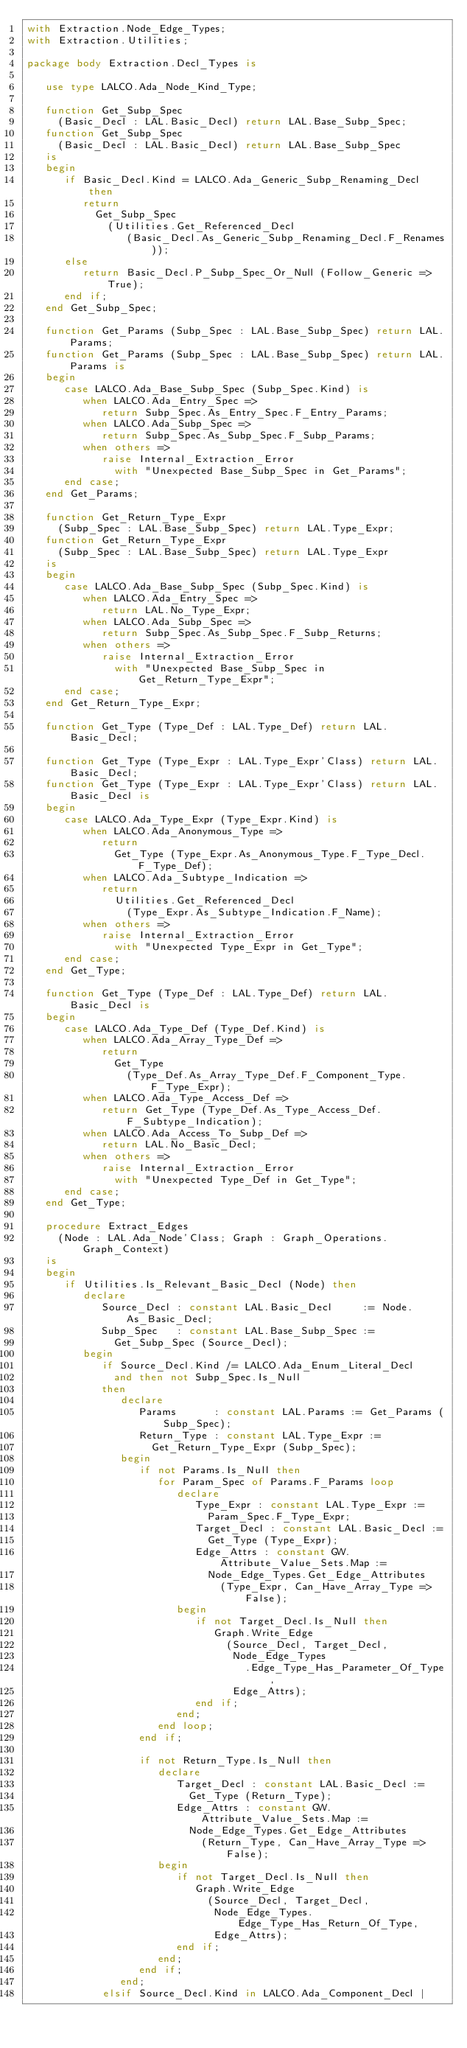Convert code to text. <code><loc_0><loc_0><loc_500><loc_500><_Ada_>with Extraction.Node_Edge_Types;
with Extraction.Utilities;

package body Extraction.Decl_Types is

   use type LALCO.Ada_Node_Kind_Type;

   function Get_Subp_Spec
     (Basic_Decl : LAL.Basic_Decl) return LAL.Base_Subp_Spec;
   function Get_Subp_Spec
     (Basic_Decl : LAL.Basic_Decl) return LAL.Base_Subp_Spec
   is
   begin
      if Basic_Decl.Kind = LALCO.Ada_Generic_Subp_Renaming_Decl then
         return
           Get_Subp_Spec
             (Utilities.Get_Referenced_Decl
                (Basic_Decl.As_Generic_Subp_Renaming_Decl.F_Renames));
      else
         return Basic_Decl.P_Subp_Spec_Or_Null (Follow_Generic => True);
      end if;
   end Get_Subp_Spec;

   function Get_Params (Subp_Spec : LAL.Base_Subp_Spec) return LAL.Params;
   function Get_Params (Subp_Spec : LAL.Base_Subp_Spec) return LAL.Params is
   begin
      case LALCO.Ada_Base_Subp_Spec (Subp_Spec.Kind) is
         when LALCO.Ada_Entry_Spec =>
            return Subp_Spec.As_Entry_Spec.F_Entry_Params;
         when LALCO.Ada_Subp_Spec =>
            return Subp_Spec.As_Subp_Spec.F_Subp_Params;
         when others =>
            raise Internal_Extraction_Error
              with "Unexpected Base_Subp_Spec in Get_Params";
      end case;
   end Get_Params;

   function Get_Return_Type_Expr
     (Subp_Spec : LAL.Base_Subp_Spec) return LAL.Type_Expr;
   function Get_Return_Type_Expr
     (Subp_Spec : LAL.Base_Subp_Spec) return LAL.Type_Expr
   is
   begin
      case LALCO.Ada_Base_Subp_Spec (Subp_Spec.Kind) is
         when LALCO.Ada_Entry_Spec =>
            return LAL.No_Type_Expr;
         when LALCO.Ada_Subp_Spec =>
            return Subp_Spec.As_Subp_Spec.F_Subp_Returns;
         when others =>
            raise Internal_Extraction_Error
              with "Unexpected Base_Subp_Spec in Get_Return_Type_Expr";
      end case;
   end Get_Return_Type_Expr;

   function Get_Type (Type_Def : LAL.Type_Def) return LAL.Basic_Decl;

   function Get_Type (Type_Expr : LAL.Type_Expr'Class) return LAL.Basic_Decl;
   function Get_Type (Type_Expr : LAL.Type_Expr'Class) return LAL.Basic_Decl is
   begin
      case LALCO.Ada_Type_Expr (Type_Expr.Kind) is
         when LALCO.Ada_Anonymous_Type =>
            return
              Get_Type (Type_Expr.As_Anonymous_Type.F_Type_Decl.F_Type_Def);
         when LALCO.Ada_Subtype_Indication =>
            return
              Utilities.Get_Referenced_Decl
                (Type_Expr.As_Subtype_Indication.F_Name);
         when others =>
            raise Internal_Extraction_Error
              with "Unexpected Type_Expr in Get_Type";
      end case;
   end Get_Type;

   function Get_Type (Type_Def : LAL.Type_Def) return LAL.Basic_Decl is
   begin
      case LALCO.Ada_Type_Def (Type_Def.Kind) is
         when LALCO.Ada_Array_Type_Def =>
            return
              Get_Type
                (Type_Def.As_Array_Type_Def.F_Component_Type.F_Type_Expr);
         when LALCO.Ada_Type_Access_Def =>
            return Get_Type (Type_Def.As_Type_Access_Def.F_Subtype_Indication);
         when LALCO.Ada_Access_To_Subp_Def =>
            return LAL.No_Basic_Decl;
         when others =>
            raise Internal_Extraction_Error
              with "Unexpected Type_Def in Get_Type";
      end case;
   end Get_Type;

   procedure Extract_Edges
     (Node : LAL.Ada_Node'Class; Graph : Graph_Operations.Graph_Context)
   is
   begin
      if Utilities.Is_Relevant_Basic_Decl (Node) then
         declare
            Source_Decl : constant LAL.Basic_Decl     := Node.As_Basic_Decl;
            Subp_Spec   : constant LAL.Base_Subp_Spec :=
              Get_Subp_Spec (Source_Decl);
         begin
            if Source_Decl.Kind /= LALCO.Ada_Enum_Literal_Decl
              and then not Subp_Spec.Is_Null
            then
               declare
                  Params      : constant LAL.Params := Get_Params (Subp_Spec);
                  Return_Type : constant LAL.Type_Expr :=
                    Get_Return_Type_Expr (Subp_Spec);
               begin
                  if not Params.Is_Null then
                     for Param_Spec of Params.F_Params loop
                        declare
                           Type_Expr : constant LAL.Type_Expr :=
                             Param_Spec.F_Type_Expr;
                           Target_Decl : constant LAL.Basic_Decl :=
                             Get_Type (Type_Expr);
                           Edge_Attrs : constant GW.Attribute_Value_Sets.Map :=
                             Node_Edge_Types.Get_Edge_Attributes
                               (Type_Expr, Can_Have_Array_Type => False);
                        begin
                           if not Target_Decl.Is_Null then
                              Graph.Write_Edge
                                (Source_Decl, Target_Decl,
                                 Node_Edge_Types
                                   .Edge_Type_Has_Parameter_Of_Type,
                                 Edge_Attrs);
                           end if;
                        end;
                     end loop;
                  end if;

                  if not Return_Type.Is_Null then
                     declare
                        Target_Decl : constant LAL.Basic_Decl :=
                          Get_Type (Return_Type);
                        Edge_Attrs : constant GW.Attribute_Value_Sets.Map :=
                          Node_Edge_Types.Get_Edge_Attributes
                            (Return_Type, Can_Have_Array_Type => False);
                     begin
                        if not Target_Decl.Is_Null then
                           Graph.Write_Edge
                             (Source_Decl, Target_Decl,
                              Node_Edge_Types.Edge_Type_Has_Return_Of_Type,
                              Edge_Attrs);
                        end if;
                     end;
                  end if;
               end;
            elsif Source_Decl.Kind in LALCO.Ada_Component_Decl |</code> 